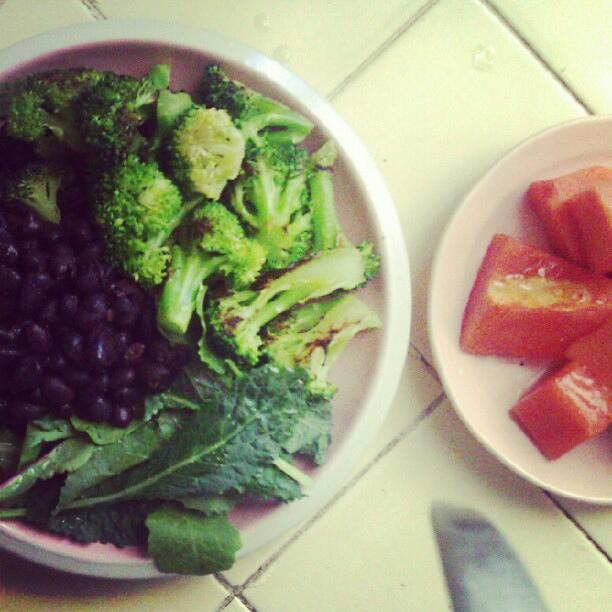Which item is likely most crispy? Please explain your reasoning. lighter green. It is raw 